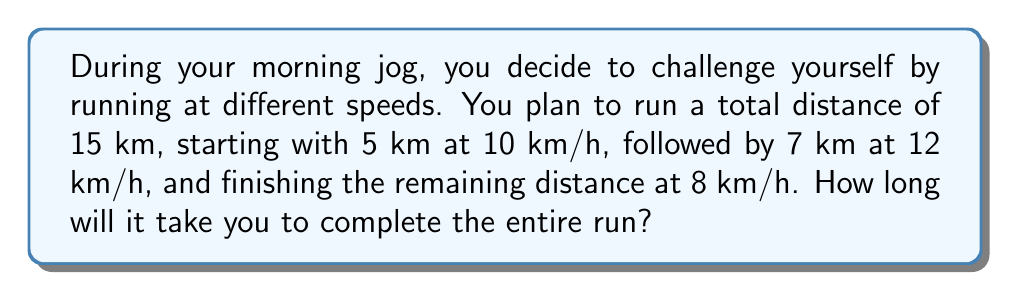Show me your answer to this math problem. Let's break this problem down into steps:

1. Calculate the time for the first 5 km:
   $t_1 = \frac{d_1}{v_1} = \frac{5 \text{ km}}{10 \text{ km/h}} = 0.5 \text{ h}$

2. Calculate the time for the next 7 km:
   $t_2 = \frac{d_2}{v_2} = \frac{7 \text{ km}}{12 \text{ km/h}} = 0.5833 \text{ h}$

3. Calculate the remaining distance:
   $d_3 = 15 \text{ km} - (5 \text{ km} + 7 \text{ km}) = 3 \text{ km}$

4. Calculate the time for the final 3 km:
   $t_3 = \frac{d_3}{v_3} = \frac{3 \text{ km}}{8 \text{ km/h}} = 0.375 \text{ h}$

5. Sum up the total time:
   $t_{\text{total}} = t_1 + t_2 + t_3 = 0.5 + 0.5833 + 0.375 = 1.4583 \text{ h}$

6. Convert the result to hours and minutes:
   $1.4583 \text{ h} = 1 \text{ h} + 0.4583 \text{ h}$
   $0.4583 \text{ h} \times 60 \text{ min/h} = 27.5 \text{ min} \approx 28 \text{ min}$

Therefore, the total time to complete the run is approximately 1 hour and 28 minutes.
Answer: 1 h 28 min 